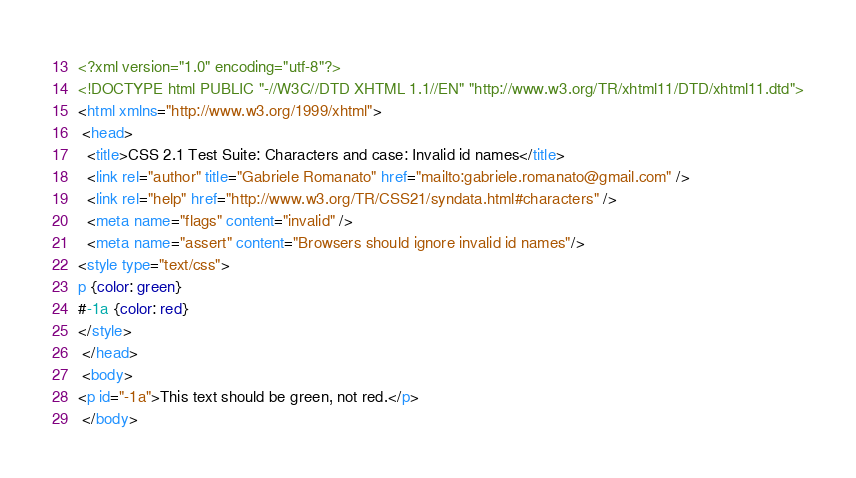Convert code to text. <code><loc_0><loc_0><loc_500><loc_500><_HTML_><?xml version="1.0" encoding="utf-8"?>
<!DOCTYPE html PUBLIC "-//W3C//DTD XHTML 1.1//EN" "http://www.w3.org/TR/xhtml11/DTD/xhtml11.dtd">
<html xmlns="http://www.w3.org/1999/xhtml">
 <head>
  <title>CSS 2.1 Test Suite: Characters and case: Invalid id names</title>
  <link rel="author" title="Gabriele Romanato" href="mailto:gabriele.romanato@gmail.com" />
  <link rel="help" href="http://www.w3.org/TR/CSS21/syndata.html#characters" />
  <meta name="flags" content="invalid" />
  <meta name="assert" content="Browsers should ignore invalid id names"/>
<style type="text/css">
p {color: green}
#-1a {color: red}
</style>
 </head>
 <body>
<p id="-1a">This text should be green, not red.</p>
 </body></code> 